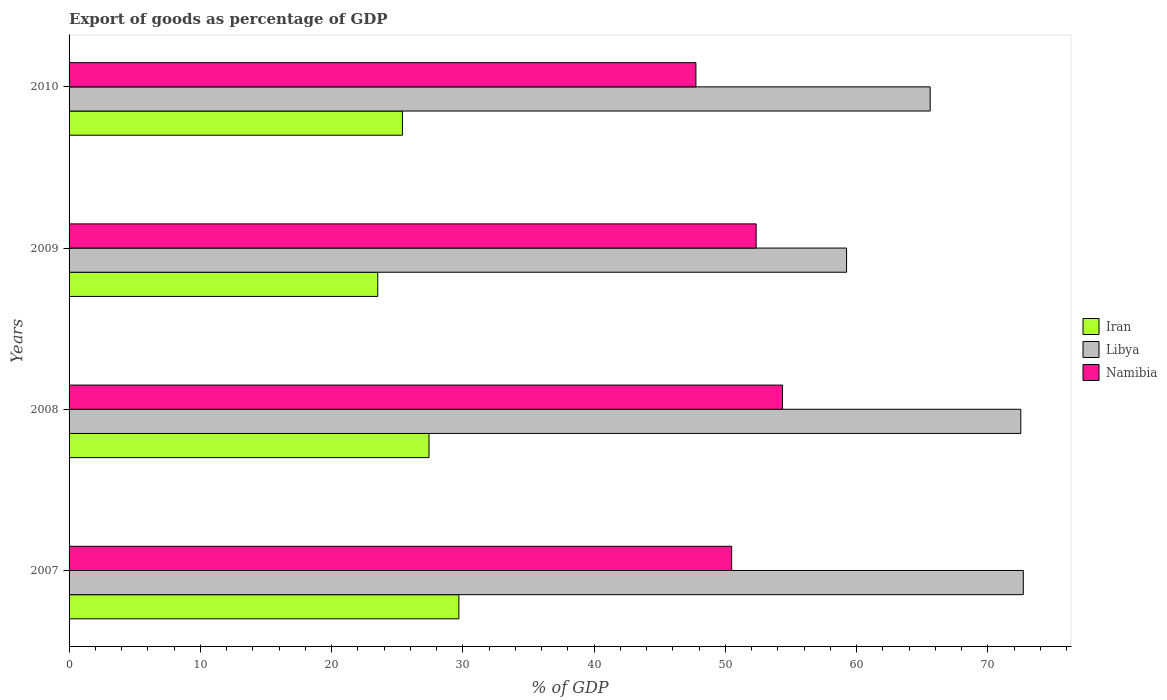Are the number of bars per tick equal to the number of legend labels?
Ensure brevity in your answer.  Yes. In how many cases, is the number of bars for a given year not equal to the number of legend labels?
Your response must be concise. 0. What is the export of goods as percentage of GDP in Libya in 2008?
Your answer should be compact. 72.51. Across all years, what is the maximum export of goods as percentage of GDP in Namibia?
Your answer should be very brief. 54.35. Across all years, what is the minimum export of goods as percentage of GDP in Libya?
Provide a short and direct response. 59.24. In which year was the export of goods as percentage of GDP in Iran maximum?
Give a very brief answer. 2007. What is the total export of goods as percentage of GDP in Namibia in the graph?
Your answer should be compact. 204.94. What is the difference between the export of goods as percentage of GDP in Libya in 2008 and that in 2009?
Your response must be concise. 13.27. What is the difference between the export of goods as percentage of GDP in Libya in 2010 and the export of goods as percentage of GDP in Iran in 2008?
Your response must be concise. 38.18. What is the average export of goods as percentage of GDP in Iran per year?
Your answer should be compact. 26.51. In the year 2008, what is the difference between the export of goods as percentage of GDP in Namibia and export of goods as percentage of GDP in Libya?
Keep it short and to the point. -18.15. What is the ratio of the export of goods as percentage of GDP in Libya in 2007 to that in 2010?
Your answer should be very brief. 1.11. What is the difference between the highest and the second highest export of goods as percentage of GDP in Libya?
Your response must be concise. 0.19. What is the difference between the highest and the lowest export of goods as percentage of GDP in Libya?
Make the answer very short. 13.46. In how many years, is the export of goods as percentage of GDP in Libya greater than the average export of goods as percentage of GDP in Libya taken over all years?
Offer a terse response. 2. What does the 1st bar from the top in 2007 represents?
Make the answer very short. Namibia. What does the 3rd bar from the bottom in 2009 represents?
Make the answer very short. Namibia. Are all the bars in the graph horizontal?
Ensure brevity in your answer.  Yes. Does the graph contain grids?
Provide a succinct answer. No. What is the title of the graph?
Give a very brief answer. Export of goods as percentage of GDP. What is the label or title of the X-axis?
Offer a very short reply. % of GDP. What is the % of GDP of Iran in 2007?
Provide a short and direct response. 29.7. What is the % of GDP in Libya in 2007?
Keep it short and to the point. 72.7. What is the % of GDP of Namibia in 2007?
Offer a very short reply. 50.48. What is the % of GDP of Iran in 2008?
Provide a short and direct response. 27.42. What is the % of GDP of Libya in 2008?
Provide a succinct answer. 72.51. What is the % of GDP of Namibia in 2008?
Your response must be concise. 54.35. What is the % of GDP of Iran in 2009?
Provide a succinct answer. 23.52. What is the % of GDP of Libya in 2009?
Give a very brief answer. 59.24. What is the % of GDP in Namibia in 2009?
Offer a terse response. 52.35. What is the % of GDP in Iran in 2010?
Your answer should be very brief. 25.4. What is the % of GDP of Libya in 2010?
Make the answer very short. 65.6. What is the % of GDP in Namibia in 2010?
Give a very brief answer. 47.76. Across all years, what is the maximum % of GDP in Iran?
Provide a short and direct response. 29.7. Across all years, what is the maximum % of GDP of Libya?
Your answer should be compact. 72.7. Across all years, what is the maximum % of GDP of Namibia?
Provide a short and direct response. 54.35. Across all years, what is the minimum % of GDP in Iran?
Your answer should be very brief. 23.52. Across all years, what is the minimum % of GDP in Libya?
Offer a very short reply. 59.24. Across all years, what is the minimum % of GDP of Namibia?
Your answer should be very brief. 47.76. What is the total % of GDP in Iran in the graph?
Keep it short and to the point. 106.04. What is the total % of GDP in Libya in the graph?
Your answer should be compact. 270.05. What is the total % of GDP in Namibia in the graph?
Give a very brief answer. 204.94. What is the difference between the % of GDP in Iran in 2007 and that in 2008?
Provide a succinct answer. 2.28. What is the difference between the % of GDP in Libya in 2007 and that in 2008?
Ensure brevity in your answer.  0.19. What is the difference between the % of GDP of Namibia in 2007 and that in 2008?
Offer a terse response. -3.87. What is the difference between the % of GDP of Iran in 2007 and that in 2009?
Give a very brief answer. 6.18. What is the difference between the % of GDP in Libya in 2007 and that in 2009?
Ensure brevity in your answer.  13.46. What is the difference between the % of GDP of Namibia in 2007 and that in 2009?
Give a very brief answer. -1.86. What is the difference between the % of GDP in Iran in 2007 and that in 2010?
Keep it short and to the point. 4.3. What is the difference between the % of GDP of Libya in 2007 and that in 2010?
Make the answer very short. 7.09. What is the difference between the % of GDP of Namibia in 2007 and that in 2010?
Provide a short and direct response. 2.73. What is the difference between the % of GDP in Iran in 2008 and that in 2009?
Give a very brief answer. 3.9. What is the difference between the % of GDP in Libya in 2008 and that in 2009?
Offer a very short reply. 13.27. What is the difference between the % of GDP of Namibia in 2008 and that in 2009?
Offer a very short reply. 2.01. What is the difference between the % of GDP of Iran in 2008 and that in 2010?
Give a very brief answer. 2.02. What is the difference between the % of GDP in Libya in 2008 and that in 2010?
Your response must be concise. 6.9. What is the difference between the % of GDP in Namibia in 2008 and that in 2010?
Your response must be concise. 6.6. What is the difference between the % of GDP in Iran in 2009 and that in 2010?
Give a very brief answer. -1.88. What is the difference between the % of GDP of Libya in 2009 and that in 2010?
Offer a terse response. -6.37. What is the difference between the % of GDP in Namibia in 2009 and that in 2010?
Your answer should be very brief. 4.59. What is the difference between the % of GDP in Iran in 2007 and the % of GDP in Libya in 2008?
Keep it short and to the point. -42.81. What is the difference between the % of GDP in Iran in 2007 and the % of GDP in Namibia in 2008?
Provide a short and direct response. -24.65. What is the difference between the % of GDP in Libya in 2007 and the % of GDP in Namibia in 2008?
Ensure brevity in your answer.  18.34. What is the difference between the % of GDP in Iran in 2007 and the % of GDP in Libya in 2009?
Offer a very short reply. -29.54. What is the difference between the % of GDP of Iran in 2007 and the % of GDP of Namibia in 2009?
Provide a succinct answer. -22.65. What is the difference between the % of GDP of Libya in 2007 and the % of GDP of Namibia in 2009?
Make the answer very short. 20.35. What is the difference between the % of GDP of Iran in 2007 and the % of GDP of Libya in 2010?
Provide a short and direct response. -35.91. What is the difference between the % of GDP of Iran in 2007 and the % of GDP of Namibia in 2010?
Keep it short and to the point. -18.06. What is the difference between the % of GDP in Libya in 2007 and the % of GDP in Namibia in 2010?
Provide a succinct answer. 24.94. What is the difference between the % of GDP in Iran in 2008 and the % of GDP in Libya in 2009?
Offer a terse response. -31.81. What is the difference between the % of GDP in Iran in 2008 and the % of GDP in Namibia in 2009?
Make the answer very short. -24.92. What is the difference between the % of GDP of Libya in 2008 and the % of GDP of Namibia in 2009?
Ensure brevity in your answer.  20.16. What is the difference between the % of GDP of Iran in 2008 and the % of GDP of Libya in 2010?
Keep it short and to the point. -38.18. What is the difference between the % of GDP of Iran in 2008 and the % of GDP of Namibia in 2010?
Ensure brevity in your answer.  -20.34. What is the difference between the % of GDP of Libya in 2008 and the % of GDP of Namibia in 2010?
Provide a short and direct response. 24.75. What is the difference between the % of GDP of Iran in 2009 and the % of GDP of Libya in 2010?
Your response must be concise. -42.09. What is the difference between the % of GDP in Iran in 2009 and the % of GDP in Namibia in 2010?
Offer a terse response. -24.24. What is the difference between the % of GDP in Libya in 2009 and the % of GDP in Namibia in 2010?
Offer a very short reply. 11.48. What is the average % of GDP of Iran per year?
Offer a very short reply. 26.51. What is the average % of GDP of Libya per year?
Your answer should be compact. 67.51. What is the average % of GDP in Namibia per year?
Your answer should be compact. 51.24. In the year 2007, what is the difference between the % of GDP of Iran and % of GDP of Libya?
Your answer should be compact. -43. In the year 2007, what is the difference between the % of GDP of Iran and % of GDP of Namibia?
Make the answer very short. -20.78. In the year 2007, what is the difference between the % of GDP of Libya and % of GDP of Namibia?
Provide a short and direct response. 22.22. In the year 2008, what is the difference between the % of GDP in Iran and % of GDP in Libya?
Your answer should be compact. -45.09. In the year 2008, what is the difference between the % of GDP of Iran and % of GDP of Namibia?
Keep it short and to the point. -26.93. In the year 2008, what is the difference between the % of GDP of Libya and % of GDP of Namibia?
Your answer should be very brief. 18.15. In the year 2009, what is the difference between the % of GDP in Iran and % of GDP in Libya?
Your answer should be very brief. -35.72. In the year 2009, what is the difference between the % of GDP in Iran and % of GDP in Namibia?
Provide a succinct answer. -28.83. In the year 2009, what is the difference between the % of GDP of Libya and % of GDP of Namibia?
Your answer should be very brief. 6.89. In the year 2010, what is the difference between the % of GDP in Iran and % of GDP in Libya?
Your answer should be compact. -40.21. In the year 2010, what is the difference between the % of GDP in Iran and % of GDP in Namibia?
Your response must be concise. -22.36. In the year 2010, what is the difference between the % of GDP of Libya and % of GDP of Namibia?
Provide a short and direct response. 17.85. What is the ratio of the % of GDP in Iran in 2007 to that in 2008?
Make the answer very short. 1.08. What is the ratio of the % of GDP in Namibia in 2007 to that in 2008?
Give a very brief answer. 0.93. What is the ratio of the % of GDP in Iran in 2007 to that in 2009?
Ensure brevity in your answer.  1.26. What is the ratio of the % of GDP of Libya in 2007 to that in 2009?
Your response must be concise. 1.23. What is the ratio of the % of GDP in Namibia in 2007 to that in 2009?
Offer a terse response. 0.96. What is the ratio of the % of GDP of Iran in 2007 to that in 2010?
Your response must be concise. 1.17. What is the ratio of the % of GDP in Libya in 2007 to that in 2010?
Keep it short and to the point. 1.11. What is the ratio of the % of GDP of Namibia in 2007 to that in 2010?
Provide a succinct answer. 1.06. What is the ratio of the % of GDP of Iran in 2008 to that in 2009?
Your response must be concise. 1.17. What is the ratio of the % of GDP in Libya in 2008 to that in 2009?
Provide a succinct answer. 1.22. What is the ratio of the % of GDP in Namibia in 2008 to that in 2009?
Your answer should be compact. 1.04. What is the ratio of the % of GDP in Iran in 2008 to that in 2010?
Keep it short and to the point. 1.08. What is the ratio of the % of GDP of Libya in 2008 to that in 2010?
Offer a terse response. 1.11. What is the ratio of the % of GDP in Namibia in 2008 to that in 2010?
Your answer should be very brief. 1.14. What is the ratio of the % of GDP in Iran in 2009 to that in 2010?
Your response must be concise. 0.93. What is the ratio of the % of GDP of Libya in 2009 to that in 2010?
Ensure brevity in your answer.  0.9. What is the ratio of the % of GDP in Namibia in 2009 to that in 2010?
Your response must be concise. 1.1. What is the difference between the highest and the second highest % of GDP of Iran?
Keep it short and to the point. 2.28. What is the difference between the highest and the second highest % of GDP in Libya?
Offer a very short reply. 0.19. What is the difference between the highest and the second highest % of GDP in Namibia?
Provide a succinct answer. 2.01. What is the difference between the highest and the lowest % of GDP of Iran?
Give a very brief answer. 6.18. What is the difference between the highest and the lowest % of GDP of Libya?
Provide a short and direct response. 13.46. What is the difference between the highest and the lowest % of GDP of Namibia?
Your answer should be very brief. 6.6. 